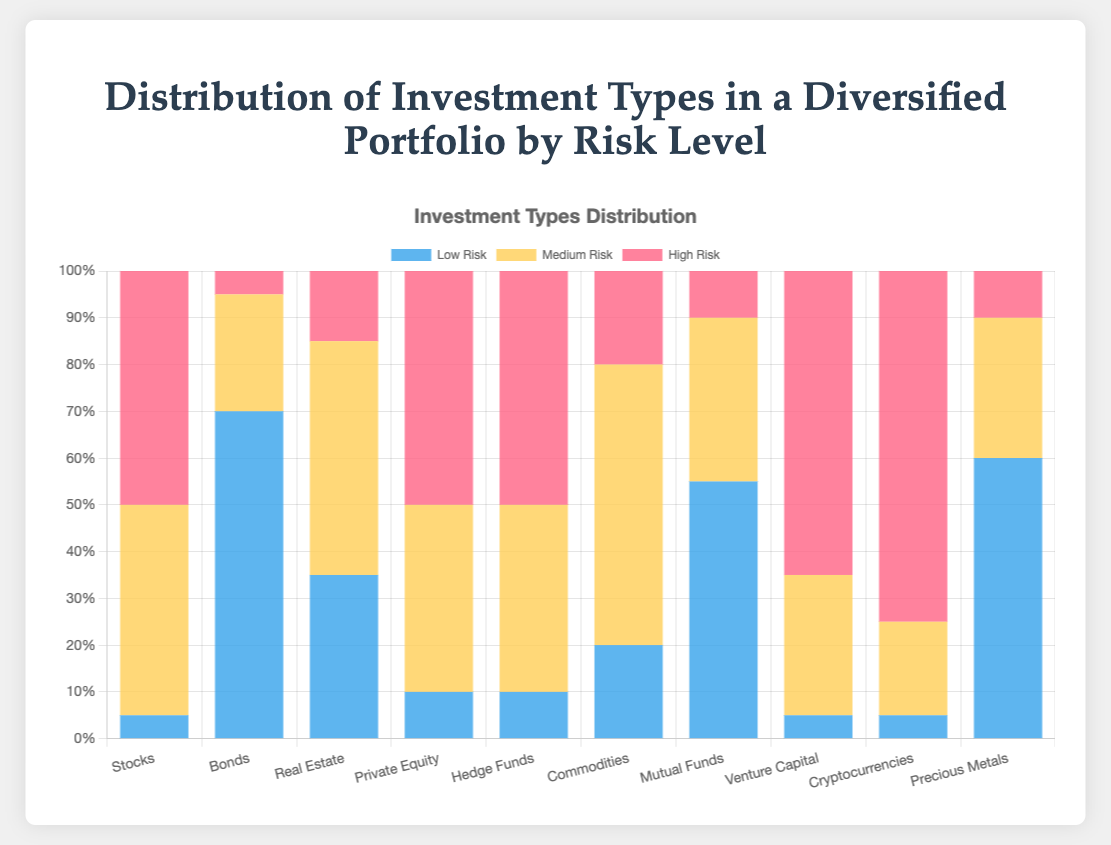Which investment type has the highest percentage of low-risk investments? By visually inspecting the stacked bar chart, identify which bar segment representing low-risk (blue color) is the largest. The "Bonds" bar has the largest blue segment at 70%.
Answer: Bonds How does the percentage of high-risk investments in venture capital compare to that in cryptocurrencies? Look at the heights of the red segments for "Venture Capital" and "Cryptocurrencies" on the stacked bar chart. Venture Capital is 65% high-risk, while Cryptocurrencies are 75% high-risk.
Answer: Cryptocurrencies have a higher percentage Which two investment types have an equal percentage of high-risk investments? Examine the red segments of the stacked bars. Both "Private Equity" and "Hedge Funds" have an equal high-risk percentage of 50%.
Answer: Private Equity and Hedge Funds What is the total percentage of medium-risk investments in Real Estate and Commodities combined? Add the medium-risk percentages for Real Estate (50%) and Commodities (60%). 50% + 60% = 110%.
Answer: 110% Do any investment types have an equal distribution across all three risk levels? Check if any stacked bars have three equal segments. None of the investment types have an equal distribution of 33.3% across low, medium, and high-risk levels.
Answer: No What is the difference in the percentage of low-risk investments between Mutual Funds and Private Equity? Subtract the low-risk percentage of Private Equity (10%) from that of Mutual Funds (55%). 55% - 10% = 45%.
Answer: 45% Which investment type has the smallest proportion of medium-risk investments? Identify the shortest yellow segment in the stacked bars. Bonds have the smallest medium-risk investment at 25%.
Answer: Bonds If you were to invest equally in Stocks, Mutual Funds, and Precious Metals, what would be the average percentage of low-risk investments? Add the low-risk percentages for Stocks (5%), Mutual Funds (55%), and Precious Metals (60%), then divide by 3: (5% + 55% + 60%)/3 = 40%.
Answer: 40% What is the sum of the high-risk investment percentages in Hedge Funds and Cryptocurrencies? Add the high-risk percentages of Hedge Funds (50%) and Cryptocurrencies (75%). 50% + 75% = 125%.
Answer: 125% Which risk level in real estate has the highest percentage? Look at the stacked bar for "Real Estate" and identify the tallest segment. The yellow segment representing medium-risk is the highest at 50%.
Answer: Medium-risk 